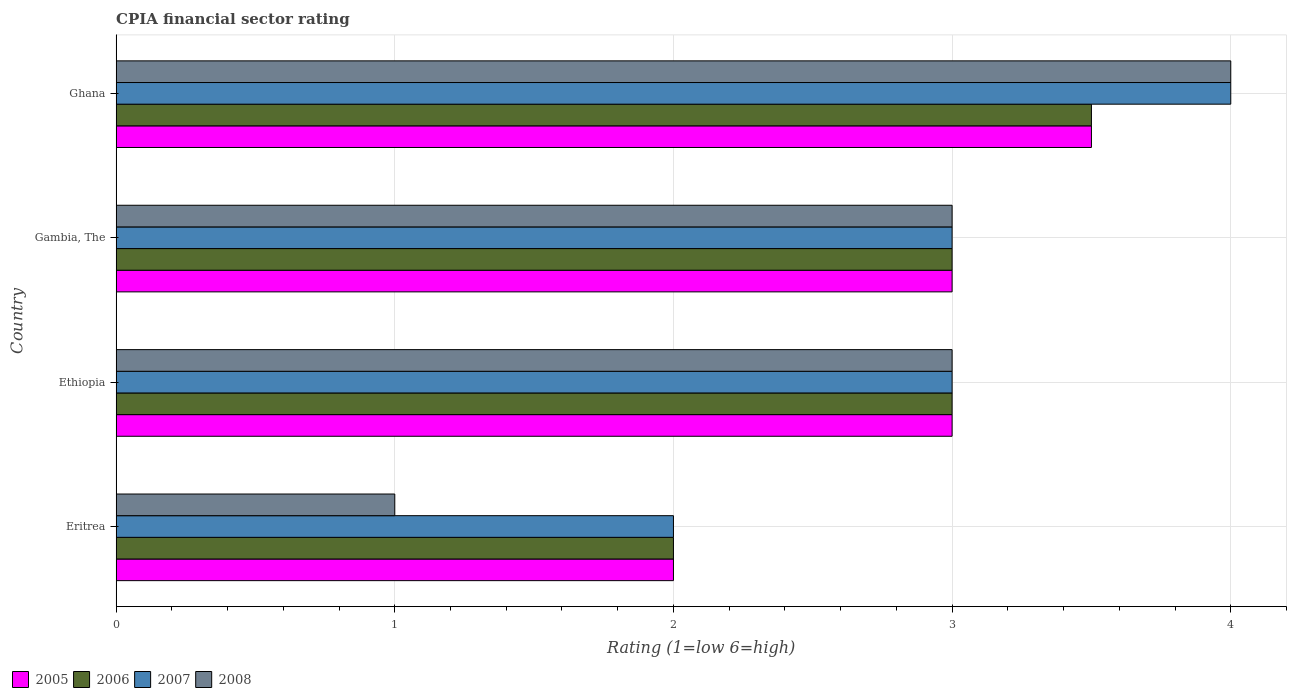How many different coloured bars are there?
Give a very brief answer. 4. How many groups of bars are there?
Your answer should be compact. 4. Are the number of bars on each tick of the Y-axis equal?
Provide a succinct answer. Yes. How many bars are there on the 3rd tick from the top?
Your answer should be very brief. 4. How many bars are there on the 3rd tick from the bottom?
Make the answer very short. 4. What is the label of the 3rd group of bars from the top?
Offer a very short reply. Ethiopia. Across all countries, what is the minimum CPIA rating in 2008?
Your answer should be very brief. 1. In which country was the CPIA rating in 2005 maximum?
Make the answer very short. Ghana. In which country was the CPIA rating in 2005 minimum?
Your answer should be compact. Eritrea. What is the total CPIA rating in 2008 in the graph?
Your answer should be compact. 11. What is the average CPIA rating in 2006 per country?
Your answer should be compact. 2.88. In how many countries, is the CPIA rating in 2006 greater than 1.6 ?
Provide a short and direct response. 4. What is the difference between the highest and the second highest CPIA rating in 2005?
Your answer should be very brief. 0.5. Is it the case that in every country, the sum of the CPIA rating in 2008 and CPIA rating in 2005 is greater than the sum of CPIA rating in 2006 and CPIA rating in 2007?
Give a very brief answer. No. What does the 2nd bar from the top in Gambia, The represents?
Give a very brief answer. 2007. What does the 1st bar from the bottom in Ghana represents?
Your answer should be compact. 2005. Is it the case that in every country, the sum of the CPIA rating in 2007 and CPIA rating in 2006 is greater than the CPIA rating in 2005?
Provide a succinct answer. Yes. How many bars are there?
Offer a terse response. 16. Are all the bars in the graph horizontal?
Make the answer very short. Yes. Are the values on the major ticks of X-axis written in scientific E-notation?
Ensure brevity in your answer.  No. Does the graph contain grids?
Provide a succinct answer. Yes. Where does the legend appear in the graph?
Your answer should be very brief. Bottom left. How many legend labels are there?
Your answer should be compact. 4. How are the legend labels stacked?
Offer a terse response. Horizontal. What is the title of the graph?
Make the answer very short. CPIA financial sector rating. Does "2004" appear as one of the legend labels in the graph?
Provide a short and direct response. No. What is the label or title of the Y-axis?
Offer a terse response. Country. What is the Rating (1=low 6=high) of 2006 in Eritrea?
Ensure brevity in your answer.  2. What is the Rating (1=low 6=high) in 2008 in Eritrea?
Provide a succinct answer. 1. What is the Rating (1=low 6=high) in 2006 in Ethiopia?
Your answer should be compact. 3. What is the Rating (1=low 6=high) in 2008 in Ethiopia?
Provide a succinct answer. 3. What is the Rating (1=low 6=high) of 2007 in Gambia, The?
Your response must be concise. 3. What is the Rating (1=low 6=high) in 2008 in Gambia, The?
Provide a succinct answer. 3. What is the Rating (1=low 6=high) of 2007 in Ghana?
Provide a short and direct response. 4. What is the Rating (1=low 6=high) of 2008 in Ghana?
Your response must be concise. 4. Across all countries, what is the maximum Rating (1=low 6=high) in 2005?
Offer a terse response. 3.5. Across all countries, what is the maximum Rating (1=low 6=high) in 2006?
Your answer should be compact. 3.5. Across all countries, what is the maximum Rating (1=low 6=high) in 2007?
Provide a short and direct response. 4. Across all countries, what is the maximum Rating (1=low 6=high) of 2008?
Offer a very short reply. 4. Across all countries, what is the minimum Rating (1=low 6=high) in 2005?
Keep it short and to the point. 2. Across all countries, what is the minimum Rating (1=low 6=high) in 2006?
Offer a terse response. 2. Across all countries, what is the minimum Rating (1=low 6=high) of 2007?
Your answer should be compact. 2. Across all countries, what is the minimum Rating (1=low 6=high) in 2008?
Your answer should be very brief. 1. What is the total Rating (1=low 6=high) of 2007 in the graph?
Give a very brief answer. 12. What is the difference between the Rating (1=low 6=high) of 2005 in Eritrea and that in Ethiopia?
Offer a very short reply. -1. What is the difference between the Rating (1=low 6=high) in 2006 in Eritrea and that in Ethiopia?
Offer a terse response. -1. What is the difference between the Rating (1=low 6=high) in 2005 in Eritrea and that in Gambia, The?
Provide a succinct answer. -1. What is the difference between the Rating (1=low 6=high) of 2006 in Eritrea and that in Gambia, The?
Your answer should be compact. -1. What is the difference between the Rating (1=low 6=high) in 2006 in Eritrea and that in Ghana?
Keep it short and to the point. -1.5. What is the difference between the Rating (1=low 6=high) of 2007 in Ethiopia and that in Gambia, The?
Keep it short and to the point. 0. What is the difference between the Rating (1=low 6=high) in 2008 in Ethiopia and that in Gambia, The?
Your answer should be very brief. 0. What is the difference between the Rating (1=low 6=high) of 2005 in Ethiopia and that in Ghana?
Your answer should be compact. -0.5. What is the difference between the Rating (1=low 6=high) in 2007 in Ethiopia and that in Ghana?
Your answer should be compact. -1. What is the difference between the Rating (1=low 6=high) in 2007 in Gambia, The and that in Ghana?
Your answer should be compact. -1. What is the difference between the Rating (1=low 6=high) of 2005 in Eritrea and the Rating (1=low 6=high) of 2006 in Ethiopia?
Keep it short and to the point. -1. What is the difference between the Rating (1=low 6=high) in 2005 in Eritrea and the Rating (1=low 6=high) in 2007 in Gambia, The?
Provide a succinct answer. -1. What is the difference between the Rating (1=low 6=high) of 2006 in Eritrea and the Rating (1=low 6=high) of 2007 in Gambia, The?
Your answer should be very brief. -1. What is the difference between the Rating (1=low 6=high) in 2006 in Eritrea and the Rating (1=low 6=high) in 2008 in Gambia, The?
Offer a very short reply. -1. What is the difference between the Rating (1=low 6=high) in 2007 in Eritrea and the Rating (1=low 6=high) in 2008 in Ghana?
Give a very brief answer. -2. What is the difference between the Rating (1=low 6=high) of 2005 in Ethiopia and the Rating (1=low 6=high) of 2007 in Gambia, The?
Keep it short and to the point. 0. What is the difference between the Rating (1=low 6=high) in 2006 in Ethiopia and the Rating (1=low 6=high) in 2007 in Gambia, The?
Ensure brevity in your answer.  0. What is the difference between the Rating (1=low 6=high) in 2005 in Ethiopia and the Rating (1=low 6=high) in 2007 in Ghana?
Give a very brief answer. -1. What is the difference between the Rating (1=low 6=high) in 2006 in Ethiopia and the Rating (1=low 6=high) in 2007 in Ghana?
Provide a succinct answer. -1. What is the difference between the Rating (1=low 6=high) of 2007 in Ethiopia and the Rating (1=low 6=high) of 2008 in Ghana?
Make the answer very short. -1. What is the difference between the Rating (1=low 6=high) in 2005 in Gambia, The and the Rating (1=low 6=high) in 2007 in Ghana?
Your answer should be compact. -1. What is the difference between the Rating (1=low 6=high) in 2006 in Gambia, The and the Rating (1=low 6=high) in 2007 in Ghana?
Offer a terse response. -1. What is the difference between the Rating (1=low 6=high) of 2006 in Gambia, The and the Rating (1=low 6=high) of 2008 in Ghana?
Give a very brief answer. -1. What is the average Rating (1=low 6=high) of 2005 per country?
Your answer should be compact. 2.88. What is the average Rating (1=low 6=high) in 2006 per country?
Offer a very short reply. 2.88. What is the average Rating (1=low 6=high) of 2008 per country?
Give a very brief answer. 2.75. What is the difference between the Rating (1=low 6=high) in 2005 and Rating (1=low 6=high) in 2007 in Eritrea?
Your answer should be very brief. 0. What is the difference between the Rating (1=low 6=high) in 2005 and Rating (1=low 6=high) in 2006 in Ethiopia?
Your answer should be very brief. 0. What is the difference between the Rating (1=low 6=high) of 2005 and Rating (1=low 6=high) of 2007 in Ethiopia?
Offer a terse response. 0. What is the difference between the Rating (1=low 6=high) in 2007 and Rating (1=low 6=high) in 2008 in Ethiopia?
Offer a very short reply. 0. What is the difference between the Rating (1=low 6=high) in 2005 and Rating (1=low 6=high) in 2007 in Gambia, The?
Your answer should be compact. 0. What is the difference between the Rating (1=low 6=high) in 2007 and Rating (1=low 6=high) in 2008 in Gambia, The?
Your response must be concise. 0. What is the difference between the Rating (1=low 6=high) in 2005 and Rating (1=low 6=high) in 2007 in Ghana?
Make the answer very short. -0.5. What is the difference between the Rating (1=low 6=high) of 2005 and Rating (1=low 6=high) of 2008 in Ghana?
Provide a short and direct response. -0.5. What is the difference between the Rating (1=low 6=high) in 2006 and Rating (1=low 6=high) in 2007 in Ghana?
Make the answer very short. -0.5. What is the difference between the Rating (1=low 6=high) in 2007 and Rating (1=low 6=high) in 2008 in Ghana?
Provide a succinct answer. 0. What is the ratio of the Rating (1=low 6=high) in 2005 in Eritrea to that in Ethiopia?
Your response must be concise. 0.67. What is the ratio of the Rating (1=low 6=high) of 2006 in Eritrea to that in Ethiopia?
Your response must be concise. 0.67. What is the ratio of the Rating (1=low 6=high) of 2007 in Eritrea to that in Ethiopia?
Your response must be concise. 0.67. What is the ratio of the Rating (1=low 6=high) in 2005 in Eritrea to that in Gambia, The?
Provide a succinct answer. 0.67. What is the ratio of the Rating (1=low 6=high) of 2007 in Eritrea to that in Gambia, The?
Ensure brevity in your answer.  0.67. What is the ratio of the Rating (1=low 6=high) of 2006 in Eritrea to that in Ghana?
Provide a succinct answer. 0.57. What is the ratio of the Rating (1=low 6=high) of 2008 in Eritrea to that in Ghana?
Give a very brief answer. 0.25. What is the ratio of the Rating (1=low 6=high) of 2007 in Ethiopia to that in Gambia, The?
Give a very brief answer. 1. What is the ratio of the Rating (1=low 6=high) in 2008 in Ethiopia to that in Gambia, The?
Give a very brief answer. 1. What is the ratio of the Rating (1=low 6=high) of 2005 in Ethiopia to that in Ghana?
Make the answer very short. 0.86. What is the ratio of the Rating (1=low 6=high) in 2008 in Ethiopia to that in Ghana?
Your answer should be compact. 0.75. What is the ratio of the Rating (1=low 6=high) in 2005 in Gambia, The to that in Ghana?
Offer a terse response. 0.86. What is the ratio of the Rating (1=low 6=high) in 2007 in Gambia, The to that in Ghana?
Your response must be concise. 0.75. What is the difference between the highest and the second highest Rating (1=low 6=high) in 2005?
Provide a short and direct response. 0.5. What is the difference between the highest and the second highest Rating (1=low 6=high) of 2006?
Ensure brevity in your answer.  0.5. What is the difference between the highest and the lowest Rating (1=low 6=high) in 2005?
Your answer should be compact. 1.5. What is the difference between the highest and the lowest Rating (1=low 6=high) of 2006?
Give a very brief answer. 1.5. 